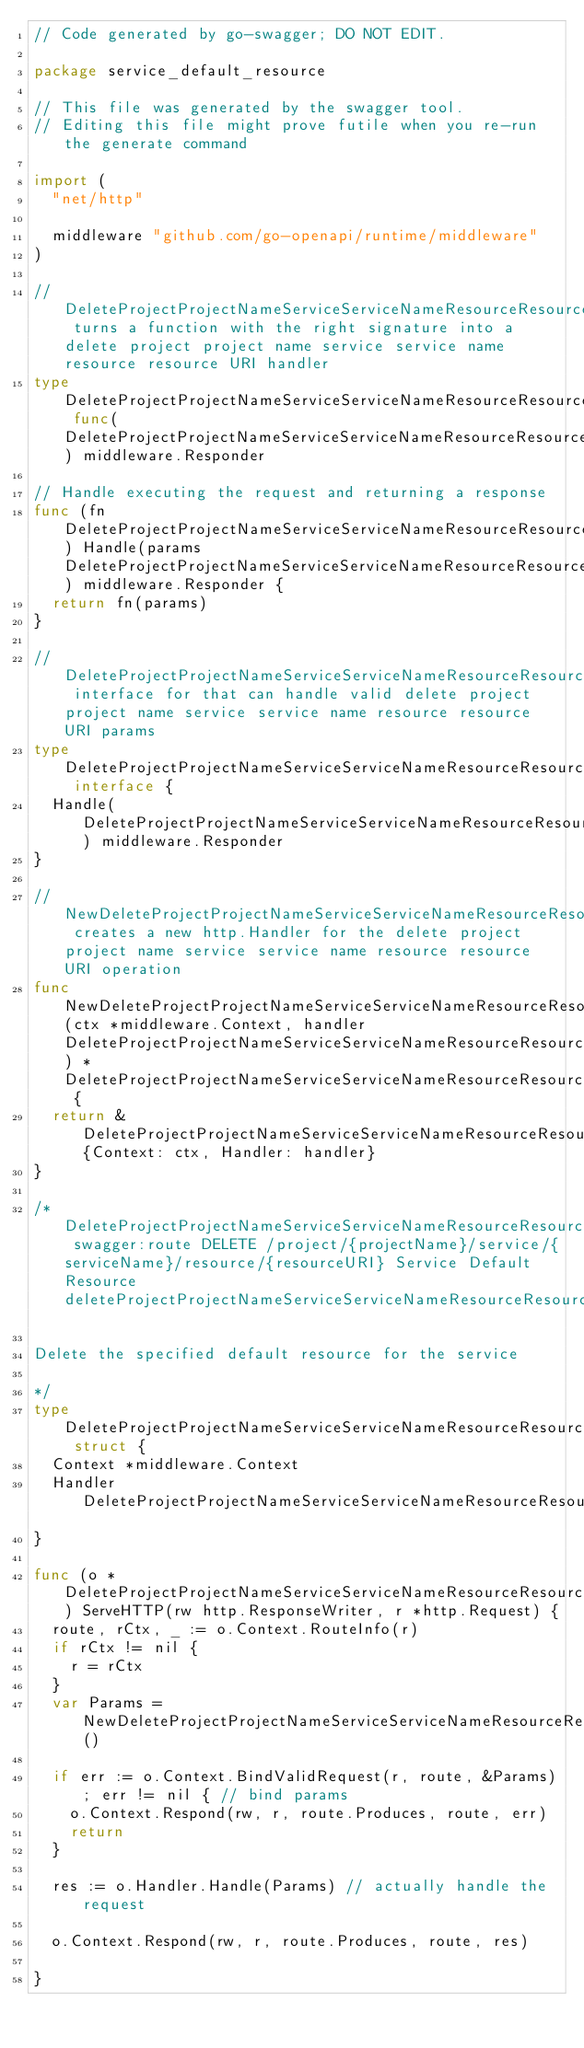<code> <loc_0><loc_0><loc_500><loc_500><_Go_>// Code generated by go-swagger; DO NOT EDIT.

package service_default_resource

// This file was generated by the swagger tool.
// Editing this file might prove futile when you re-run the generate command

import (
	"net/http"

	middleware "github.com/go-openapi/runtime/middleware"
)

// DeleteProjectProjectNameServiceServiceNameResourceResourceURIHandlerFunc turns a function with the right signature into a delete project project name service service name resource resource URI handler
type DeleteProjectProjectNameServiceServiceNameResourceResourceURIHandlerFunc func(DeleteProjectProjectNameServiceServiceNameResourceResourceURIParams) middleware.Responder

// Handle executing the request and returning a response
func (fn DeleteProjectProjectNameServiceServiceNameResourceResourceURIHandlerFunc) Handle(params DeleteProjectProjectNameServiceServiceNameResourceResourceURIParams) middleware.Responder {
	return fn(params)
}

// DeleteProjectProjectNameServiceServiceNameResourceResourceURIHandler interface for that can handle valid delete project project name service service name resource resource URI params
type DeleteProjectProjectNameServiceServiceNameResourceResourceURIHandler interface {
	Handle(DeleteProjectProjectNameServiceServiceNameResourceResourceURIParams) middleware.Responder
}

// NewDeleteProjectProjectNameServiceServiceNameResourceResourceURI creates a new http.Handler for the delete project project name service service name resource resource URI operation
func NewDeleteProjectProjectNameServiceServiceNameResourceResourceURI(ctx *middleware.Context, handler DeleteProjectProjectNameServiceServiceNameResourceResourceURIHandler) *DeleteProjectProjectNameServiceServiceNameResourceResourceURI {
	return &DeleteProjectProjectNameServiceServiceNameResourceResourceURI{Context: ctx, Handler: handler}
}

/*DeleteProjectProjectNameServiceServiceNameResourceResourceURI swagger:route DELETE /project/{projectName}/service/{serviceName}/resource/{resourceURI} Service Default Resource deleteProjectProjectNameServiceServiceNameResourceResourceUri

Delete the specified default resource for the service

*/
type DeleteProjectProjectNameServiceServiceNameResourceResourceURI struct {
	Context *middleware.Context
	Handler DeleteProjectProjectNameServiceServiceNameResourceResourceURIHandler
}

func (o *DeleteProjectProjectNameServiceServiceNameResourceResourceURI) ServeHTTP(rw http.ResponseWriter, r *http.Request) {
	route, rCtx, _ := o.Context.RouteInfo(r)
	if rCtx != nil {
		r = rCtx
	}
	var Params = NewDeleteProjectProjectNameServiceServiceNameResourceResourceURIParams()

	if err := o.Context.BindValidRequest(r, route, &Params); err != nil { // bind params
		o.Context.Respond(rw, r, route.Produces, route, err)
		return
	}

	res := o.Handler.Handle(Params) // actually handle the request

	o.Context.Respond(rw, r, route.Produces, route, res)

}
</code> 